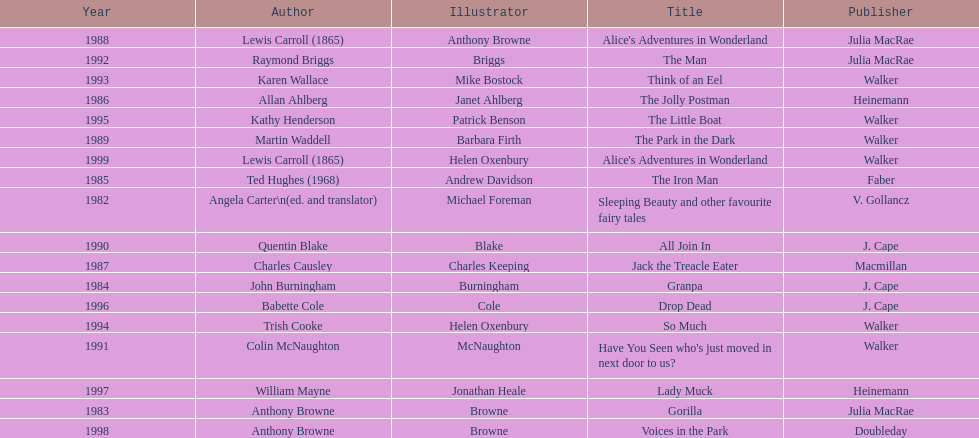Helen oxenbury has won how many kurt maschler awards? 2. 